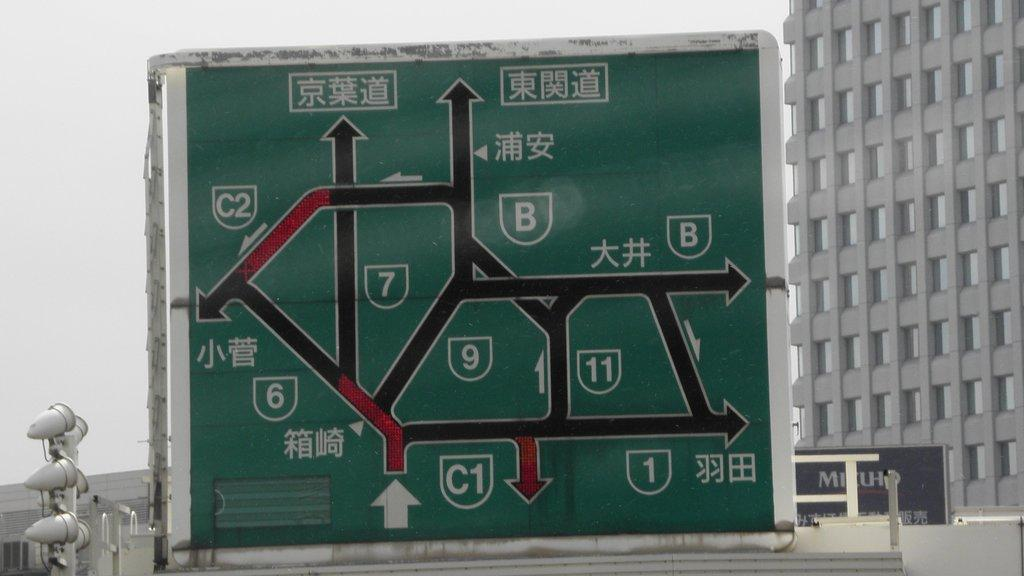<image>
Provide a brief description of the given image. A road sign has the number 6 and 7 on it. 